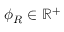<formula> <loc_0><loc_0><loc_500><loc_500>\phi _ { R } \in \mathbb { R } ^ { + }</formula> 